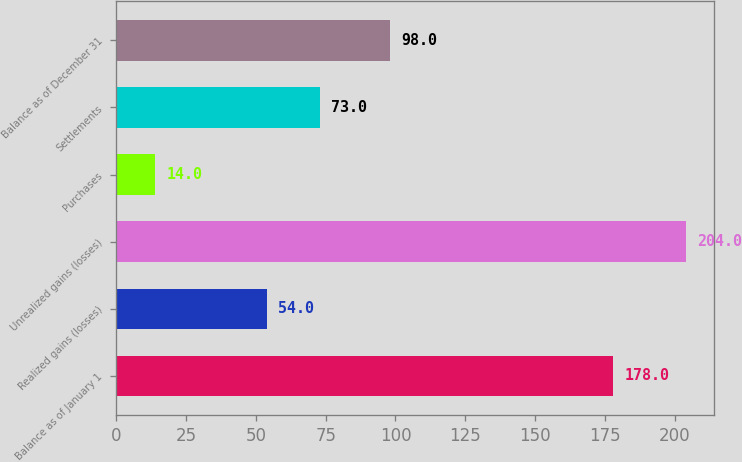Convert chart to OTSL. <chart><loc_0><loc_0><loc_500><loc_500><bar_chart><fcel>Balance as of January 1<fcel>Realized gains (losses)<fcel>Unrealized gains (losses)<fcel>Purchases<fcel>Settlements<fcel>Balance as of December 31<nl><fcel>178<fcel>54<fcel>204<fcel>14<fcel>73<fcel>98<nl></chart> 